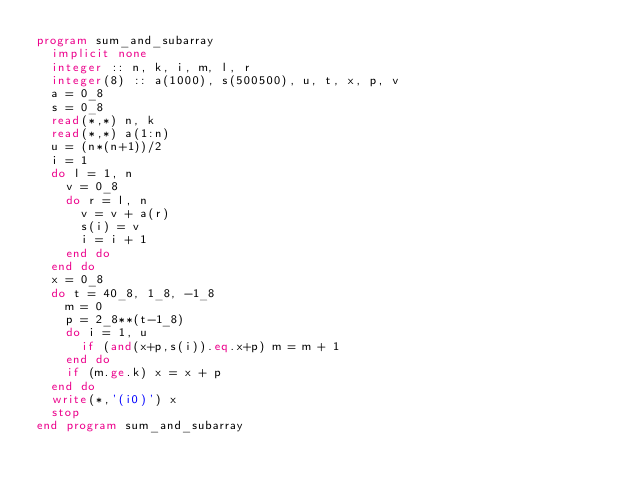Convert code to text. <code><loc_0><loc_0><loc_500><loc_500><_FORTRAN_>program sum_and_subarray
  implicit none
  integer :: n, k, i, m, l, r
  integer(8) :: a(1000), s(500500), u, t, x, p, v
  a = 0_8
  s = 0_8
  read(*,*) n, k
  read(*,*) a(1:n)
  u = (n*(n+1))/2
  i = 1
  do l = 1, n
    v = 0_8
    do r = l, n
      v = v + a(r)
      s(i) = v
      i = i + 1
    end do
  end do
  x = 0_8
  do t = 40_8, 1_8, -1_8
    m = 0
    p = 2_8**(t-1_8)
    do i = 1, u
      if (and(x+p,s(i)).eq.x+p) m = m + 1
    end do
    if (m.ge.k) x = x + p
  end do
  write(*,'(i0)') x
  stop
end program sum_and_subarray</code> 